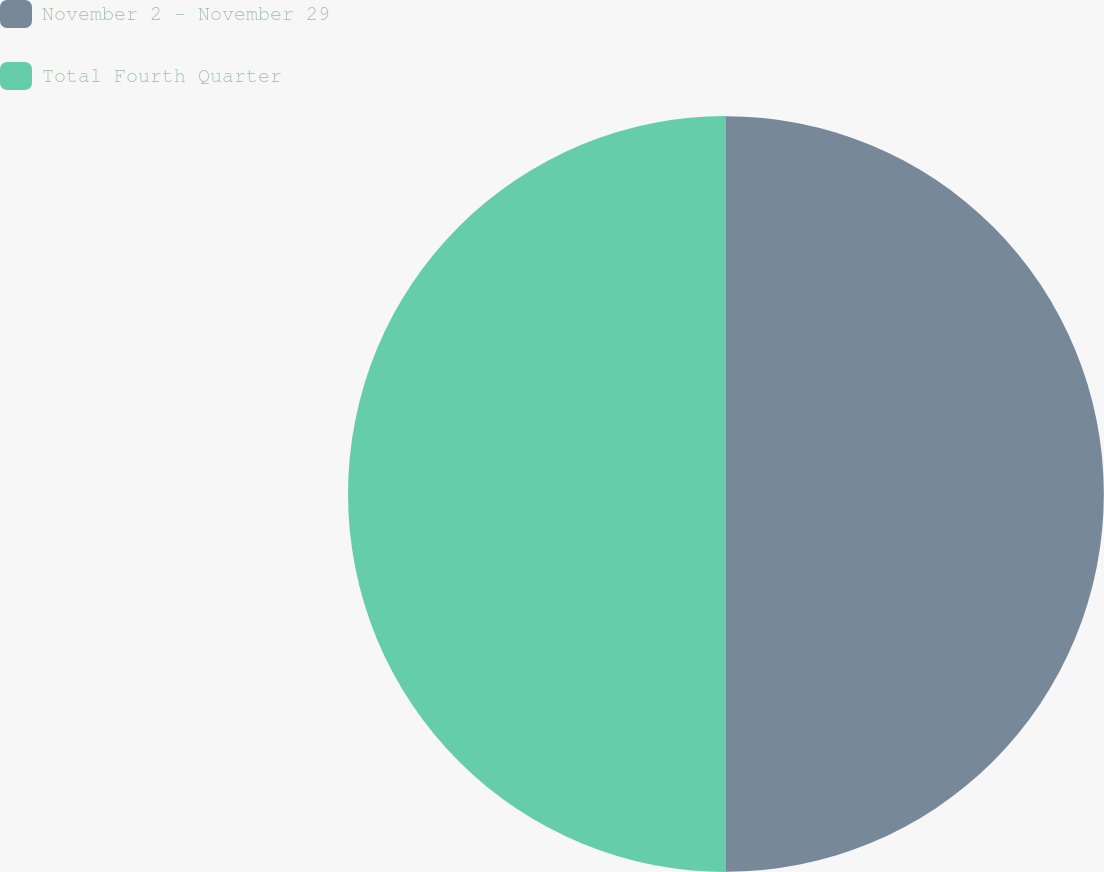Convert chart. <chart><loc_0><loc_0><loc_500><loc_500><pie_chart><fcel>November 2 - November 29<fcel>Total Fourth Quarter<nl><fcel>49.99%<fcel>50.01%<nl></chart> 